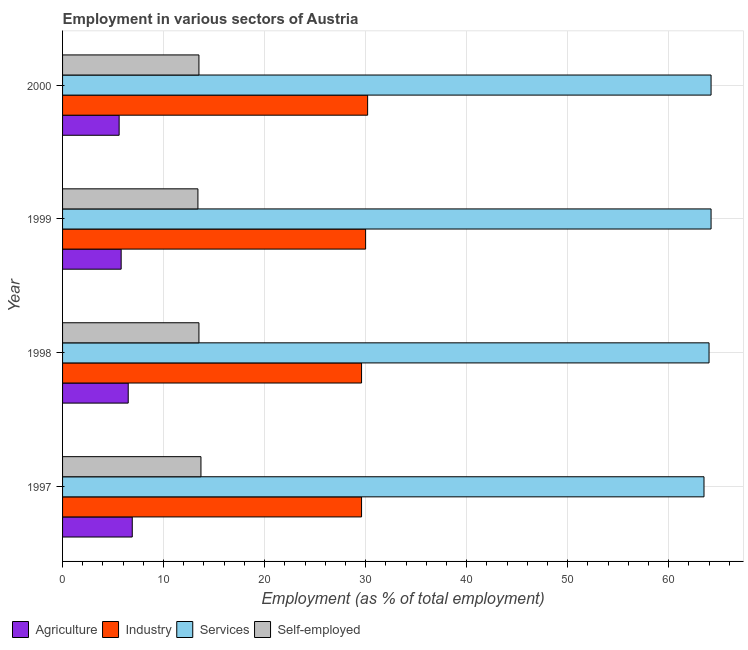How many different coloured bars are there?
Your answer should be compact. 4. How many groups of bars are there?
Your answer should be compact. 4. How many bars are there on the 4th tick from the top?
Offer a terse response. 4. How many bars are there on the 3rd tick from the bottom?
Offer a very short reply. 4. What is the label of the 4th group of bars from the top?
Offer a very short reply. 1997. What is the percentage of workers in agriculture in 1997?
Give a very brief answer. 6.9. Across all years, what is the maximum percentage of workers in services?
Provide a short and direct response. 64.2. Across all years, what is the minimum percentage of workers in industry?
Your answer should be very brief. 29.6. In which year was the percentage of workers in agriculture minimum?
Offer a very short reply. 2000. What is the total percentage of workers in industry in the graph?
Your response must be concise. 119.4. What is the difference between the percentage of workers in industry in 2000 and the percentage of self employed workers in 1997?
Your answer should be compact. 16.5. What is the average percentage of workers in services per year?
Offer a terse response. 63.98. In the year 2000, what is the difference between the percentage of self employed workers and percentage of workers in industry?
Keep it short and to the point. -16.7. Is the percentage of self employed workers in 1999 less than that in 2000?
Offer a very short reply. Yes. What is the difference between the highest and the second highest percentage of workers in agriculture?
Your answer should be compact. 0.4. What is the difference between the highest and the lowest percentage of workers in industry?
Keep it short and to the point. 0.6. In how many years, is the percentage of workers in agriculture greater than the average percentage of workers in agriculture taken over all years?
Offer a terse response. 2. What does the 3rd bar from the top in 1997 represents?
Ensure brevity in your answer.  Industry. What does the 2nd bar from the bottom in 1997 represents?
Your answer should be very brief. Industry. How many bars are there?
Your answer should be very brief. 16. Are all the bars in the graph horizontal?
Your answer should be compact. Yes. What is the difference between two consecutive major ticks on the X-axis?
Make the answer very short. 10. Does the graph contain any zero values?
Keep it short and to the point. No. Does the graph contain grids?
Offer a very short reply. Yes. How are the legend labels stacked?
Keep it short and to the point. Horizontal. What is the title of the graph?
Keep it short and to the point. Employment in various sectors of Austria. Does "Others" appear as one of the legend labels in the graph?
Your answer should be compact. No. What is the label or title of the X-axis?
Offer a very short reply. Employment (as % of total employment). What is the label or title of the Y-axis?
Make the answer very short. Year. What is the Employment (as % of total employment) of Agriculture in 1997?
Ensure brevity in your answer.  6.9. What is the Employment (as % of total employment) of Industry in 1997?
Make the answer very short. 29.6. What is the Employment (as % of total employment) of Services in 1997?
Keep it short and to the point. 63.5. What is the Employment (as % of total employment) of Self-employed in 1997?
Your answer should be very brief. 13.7. What is the Employment (as % of total employment) in Industry in 1998?
Provide a short and direct response. 29.6. What is the Employment (as % of total employment) in Services in 1998?
Your answer should be very brief. 64. What is the Employment (as % of total employment) in Self-employed in 1998?
Your response must be concise. 13.5. What is the Employment (as % of total employment) of Agriculture in 1999?
Your response must be concise. 5.8. What is the Employment (as % of total employment) in Services in 1999?
Your answer should be compact. 64.2. What is the Employment (as % of total employment) of Self-employed in 1999?
Offer a terse response. 13.4. What is the Employment (as % of total employment) in Agriculture in 2000?
Give a very brief answer. 5.6. What is the Employment (as % of total employment) in Industry in 2000?
Keep it short and to the point. 30.2. What is the Employment (as % of total employment) of Services in 2000?
Offer a terse response. 64.2. What is the Employment (as % of total employment) of Self-employed in 2000?
Keep it short and to the point. 13.5. Across all years, what is the maximum Employment (as % of total employment) in Agriculture?
Offer a terse response. 6.9. Across all years, what is the maximum Employment (as % of total employment) of Industry?
Offer a terse response. 30.2. Across all years, what is the maximum Employment (as % of total employment) of Services?
Make the answer very short. 64.2. Across all years, what is the maximum Employment (as % of total employment) in Self-employed?
Offer a terse response. 13.7. Across all years, what is the minimum Employment (as % of total employment) of Agriculture?
Make the answer very short. 5.6. Across all years, what is the minimum Employment (as % of total employment) of Industry?
Provide a succinct answer. 29.6. Across all years, what is the minimum Employment (as % of total employment) of Services?
Your answer should be very brief. 63.5. Across all years, what is the minimum Employment (as % of total employment) of Self-employed?
Your response must be concise. 13.4. What is the total Employment (as % of total employment) of Agriculture in the graph?
Your answer should be very brief. 24.8. What is the total Employment (as % of total employment) in Industry in the graph?
Your response must be concise. 119.4. What is the total Employment (as % of total employment) in Services in the graph?
Ensure brevity in your answer.  255.9. What is the total Employment (as % of total employment) in Self-employed in the graph?
Keep it short and to the point. 54.1. What is the difference between the Employment (as % of total employment) of Agriculture in 1997 and that in 1998?
Offer a terse response. 0.4. What is the difference between the Employment (as % of total employment) of Industry in 1997 and that in 1998?
Offer a terse response. 0. What is the difference between the Employment (as % of total employment) of Services in 1997 and that in 1998?
Make the answer very short. -0.5. What is the difference between the Employment (as % of total employment) of Agriculture in 1997 and that in 1999?
Provide a short and direct response. 1.1. What is the difference between the Employment (as % of total employment) of Industry in 1997 and that in 1999?
Your response must be concise. -0.4. What is the difference between the Employment (as % of total employment) of Services in 1997 and that in 1999?
Provide a short and direct response. -0.7. What is the difference between the Employment (as % of total employment) in Self-employed in 1997 and that in 1999?
Provide a succinct answer. 0.3. What is the difference between the Employment (as % of total employment) of Agriculture in 1997 and that in 2000?
Provide a short and direct response. 1.3. What is the difference between the Employment (as % of total employment) in Industry in 1997 and that in 2000?
Your answer should be compact. -0.6. What is the difference between the Employment (as % of total employment) of Services in 1997 and that in 2000?
Make the answer very short. -0.7. What is the difference between the Employment (as % of total employment) in Agriculture in 1998 and that in 1999?
Offer a terse response. 0.7. What is the difference between the Employment (as % of total employment) of Industry in 1998 and that in 1999?
Keep it short and to the point. -0.4. What is the difference between the Employment (as % of total employment) of Services in 1998 and that in 1999?
Provide a short and direct response. -0.2. What is the difference between the Employment (as % of total employment) of Agriculture in 1998 and that in 2000?
Provide a succinct answer. 0.9. What is the difference between the Employment (as % of total employment) of Industry in 1998 and that in 2000?
Your answer should be compact. -0.6. What is the difference between the Employment (as % of total employment) in Services in 1998 and that in 2000?
Ensure brevity in your answer.  -0.2. What is the difference between the Employment (as % of total employment) in Industry in 1999 and that in 2000?
Provide a short and direct response. -0.2. What is the difference between the Employment (as % of total employment) in Services in 1999 and that in 2000?
Ensure brevity in your answer.  0. What is the difference between the Employment (as % of total employment) of Agriculture in 1997 and the Employment (as % of total employment) of Industry in 1998?
Give a very brief answer. -22.7. What is the difference between the Employment (as % of total employment) in Agriculture in 1997 and the Employment (as % of total employment) in Services in 1998?
Your answer should be compact. -57.1. What is the difference between the Employment (as % of total employment) of Agriculture in 1997 and the Employment (as % of total employment) of Self-employed in 1998?
Your answer should be very brief. -6.6. What is the difference between the Employment (as % of total employment) of Industry in 1997 and the Employment (as % of total employment) of Services in 1998?
Offer a very short reply. -34.4. What is the difference between the Employment (as % of total employment) in Industry in 1997 and the Employment (as % of total employment) in Self-employed in 1998?
Your response must be concise. 16.1. What is the difference between the Employment (as % of total employment) of Agriculture in 1997 and the Employment (as % of total employment) of Industry in 1999?
Provide a succinct answer. -23.1. What is the difference between the Employment (as % of total employment) in Agriculture in 1997 and the Employment (as % of total employment) in Services in 1999?
Your answer should be very brief. -57.3. What is the difference between the Employment (as % of total employment) in Agriculture in 1997 and the Employment (as % of total employment) in Self-employed in 1999?
Your answer should be compact. -6.5. What is the difference between the Employment (as % of total employment) of Industry in 1997 and the Employment (as % of total employment) of Services in 1999?
Provide a succinct answer. -34.6. What is the difference between the Employment (as % of total employment) of Services in 1997 and the Employment (as % of total employment) of Self-employed in 1999?
Your answer should be compact. 50.1. What is the difference between the Employment (as % of total employment) of Agriculture in 1997 and the Employment (as % of total employment) of Industry in 2000?
Make the answer very short. -23.3. What is the difference between the Employment (as % of total employment) in Agriculture in 1997 and the Employment (as % of total employment) in Services in 2000?
Provide a short and direct response. -57.3. What is the difference between the Employment (as % of total employment) in Agriculture in 1997 and the Employment (as % of total employment) in Self-employed in 2000?
Make the answer very short. -6.6. What is the difference between the Employment (as % of total employment) in Industry in 1997 and the Employment (as % of total employment) in Services in 2000?
Offer a terse response. -34.6. What is the difference between the Employment (as % of total employment) of Agriculture in 1998 and the Employment (as % of total employment) of Industry in 1999?
Keep it short and to the point. -23.5. What is the difference between the Employment (as % of total employment) of Agriculture in 1998 and the Employment (as % of total employment) of Services in 1999?
Your answer should be compact. -57.7. What is the difference between the Employment (as % of total employment) in Agriculture in 1998 and the Employment (as % of total employment) in Self-employed in 1999?
Provide a succinct answer. -6.9. What is the difference between the Employment (as % of total employment) in Industry in 1998 and the Employment (as % of total employment) in Services in 1999?
Give a very brief answer. -34.6. What is the difference between the Employment (as % of total employment) of Services in 1998 and the Employment (as % of total employment) of Self-employed in 1999?
Offer a very short reply. 50.6. What is the difference between the Employment (as % of total employment) of Agriculture in 1998 and the Employment (as % of total employment) of Industry in 2000?
Ensure brevity in your answer.  -23.7. What is the difference between the Employment (as % of total employment) of Agriculture in 1998 and the Employment (as % of total employment) of Services in 2000?
Offer a very short reply. -57.7. What is the difference between the Employment (as % of total employment) in Agriculture in 1998 and the Employment (as % of total employment) in Self-employed in 2000?
Make the answer very short. -7. What is the difference between the Employment (as % of total employment) in Industry in 1998 and the Employment (as % of total employment) in Services in 2000?
Keep it short and to the point. -34.6. What is the difference between the Employment (as % of total employment) in Services in 1998 and the Employment (as % of total employment) in Self-employed in 2000?
Provide a short and direct response. 50.5. What is the difference between the Employment (as % of total employment) in Agriculture in 1999 and the Employment (as % of total employment) in Industry in 2000?
Provide a short and direct response. -24.4. What is the difference between the Employment (as % of total employment) in Agriculture in 1999 and the Employment (as % of total employment) in Services in 2000?
Your answer should be very brief. -58.4. What is the difference between the Employment (as % of total employment) of Industry in 1999 and the Employment (as % of total employment) of Services in 2000?
Ensure brevity in your answer.  -34.2. What is the difference between the Employment (as % of total employment) of Industry in 1999 and the Employment (as % of total employment) of Self-employed in 2000?
Offer a very short reply. 16.5. What is the difference between the Employment (as % of total employment) in Services in 1999 and the Employment (as % of total employment) in Self-employed in 2000?
Keep it short and to the point. 50.7. What is the average Employment (as % of total employment) of Agriculture per year?
Your answer should be compact. 6.2. What is the average Employment (as % of total employment) of Industry per year?
Offer a very short reply. 29.85. What is the average Employment (as % of total employment) in Services per year?
Offer a very short reply. 63.98. What is the average Employment (as % of total employment) of Self-employed per year?
Offer a very short reply. 13.53. In the year 1997, what is the difference between the Employment (as % of total employment) in Agriculture and Employment (as % of total employment) in Industry?
Your answer should be very brief. -22.7. In the year 1997, what is the difference between the Employment (as % of total employment) of Agriculture and Employment (as % of total employment) of Services?
Your response must be concise. -56.6. In the year 1997, what is the difference between the Employment (as % of total employment) in Agriculture and Employment (as % of total employment) in Self-employed?
Provide a short and direct response. -6.8. In the year 1997, what is the difference between the Employment (as % of total employment) in Industry and Employment (as % of total employment) in Services?
Give a very brief answer. -33.9. In the year 1997, what is the difference between the Employment (as % of total employment) in Industry and Employment (as % of total employment) in Self-employed?
Offer a very short reply. 15.9. In the year 1997, what is the difference between the Employment (as % of total employment) in Services and Employment (as % of total employment) in Self-employed?
Your response must be concise. 49.8. In the year 1998, what is the difference between the Employment (as % of total employment) of Agriculture and Employment (as % of total employment) of Industry?
Provide a short and direct response. -23.1. In the year 1998, what is the difference between the Employment (as % of total employment) in Agriculture and Employment (as % of total employment) in Services?
Make the answer very short. -57.5. In the year 1998, what is the difference between the Employment (as % of total employment) in Industry and Employment (as % of total employment) in Services?
Keep it short and to the point. -34.4. In the year 1998, what is the difference between the Employment (as % of total employment) of Industry and Employment (as % of total employment) of Self-employed?
Your answer should be very brief. 16.1. In the year 1998, what is the difference between the Employment (as % of total employment) of Services and Employment (as % of total employment) of Self-employed?
Offer a terse response. 50.5. In the year 1999, what is the difference between the Employment (as % of total employment) in Agriculture and Employment (as % of total employment) in Industry?
Provide a succinct answer. -24.2. In the year 1999, what is the difference between the Employment (as % of total employment) in Agriculture and Employment (as % of total employment) in Services?
Ensure brevity in your answer.  -58.4. In the year 1999, what is the difference between the Employment (as % of total employment) in Agriculture and Employment (as % of total employment) in Self-employed?
Make the answer very short. -7.6. In the year 1999, what is the difference between the Employment (as % of total employment) of Industry and Employment (as % of total employment) of Services?
Keep it short and to the point. -34.2. In the year 1999, what is the difference between the Employment (as % of total employment) in Services and Employment (as % of total employment) in Self-employed?
Ensure brevity in your answer.  50.8. In the year 2000, what is the difference between the Employment (as % of total employment) in Agriculture and Employment (as % of total employment) in Industry?
Provide a short and direct response. -24.6. In the year 2000, what is the difference between the Employment (as % of total employment) in Agriculture and Employment (as % of total employment) in Services?
Your answer should be very brief. -58.6. In the year 2000, what is the difference between the Employment (as % of total employment) in Agriculture and Employment (as % of total employment) in Self-employed?
Ensure brevity in your answer.  -7.9. In the year 2000, what is the difference between the Employment (as % of total employment) in Industry and Employment (as % of total employment) in Services?
Provide a succinct answer. -34. In the year 2000, what is the difference between the Employment (as % of total employment) of Industry and Employment (as % of total employment) of Self-employed?
Provide a succinct answer. 16.7. In the year 2000, what is the difference between the Employment (as % of total employment) of Services and Employment (as % of total employment) of Self-employed?
Your response must be concise. 50.7. What is the ratio of the Employment (as % of total employment) of Agriculture in 1997 to that in 1998?
Your answer should be compact. 1.06. What is the ratio of the Employment (as % of total employment) of Services in 1997 to that in 1998?
Your answer should be compact. 0.99. What is the ratio of the Employment (as % of total employment) in Self-employed in 1997 to that in 1998?
Offer a very short reply. 1.01. What is the ratio of the Employment (as % of total employment) in Agriculture in 1997 to that in 1999?
Your response must be concise. 1.19. What is the ratio of the Employment (as % of total employment) in Industry in 1997 to that in 1999?
Your response must be concise. 0.99. What is the ratio of the Employment (as % of total employment) of Self-employed in 1997 to that in 1999?
Keep it short and to the point. 1.02. What is the ratio of the Employment (as % of total employment) of Agriculture in 1997 to that in 2000?
Provide a short and direct response. 1.23. What is the ratio of the Employment (as % of total employment) of Industry in 1997 to that in 2000?
Provide a short and direct response. 0.98. What is the ratio of the Employment (as % of total employment) of Self-employed in 1997 to that in 2000?
Give a very brief answer. 1.01. What is the ratio of the Employment (as % of total employment) of Agriculture in 1998 to that in 1999?
Offer a terse response. 1.12. What is the ratio of the Employment (as % of total employment) in Industry in 1998 to that in 1999?
Keep it short and to the point. 0.99. What is the ratio of the Employment (as % of total employment) in Self-employed in 1998 to that in 1999?
Ensure brevity in your answer.  1.01. What is the ratio of the Employment (as % of total employment) in Agriculture in 1998 to that in 2000?
Offer a terse response. 1.16. What is the ratio of the Employment (as % of total employment) in Industry in 1998 to that in 2000?
Offer a terse response. 0.98. What is the ratio of the Employment (as % of total employment) of Services in 1998 to that in 2000?
Offer a very short reply. 1. What is the ratio of the Employment (as % of total employment) in Agriculture in 1999 to that in 2000?
Offer a very short reply. 1.04. What is the ratio of the Employment (as % of total employment) of Services in 1999 to that in 2000?
Make the answer very short. 1. What is the difference between the highest and the second highest Employment (as % of total employment) of Agriculture?
Give a very brief answer. 0.4. What is the difference between the highest and the second highest Employment (as % of total employment) of Services?
Offer a very short reply. 0. What is the difference between the highest and the lowest Employment (as % of total employment) in Agriculture?
Offer a terse response. 1.3. What is the difference between the highest and the lowest Employment (as % of total employment) of Services?
Provide a short and direct response. 0.7. 